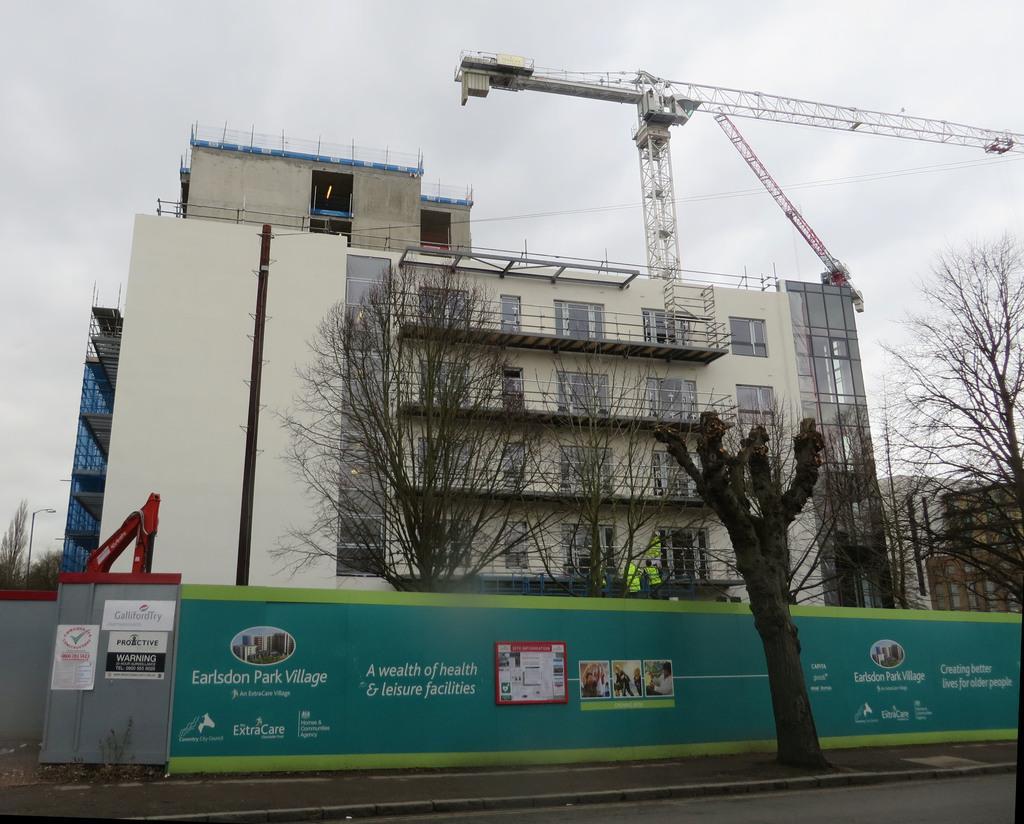Could you give a brief overview of what you see in this image? In the background we can see the sky. In this picture we can see a building, windows, hoarding, light pole, posters, trees, tower crane and few objects. At the bottom portion of the picture we can see the road. 